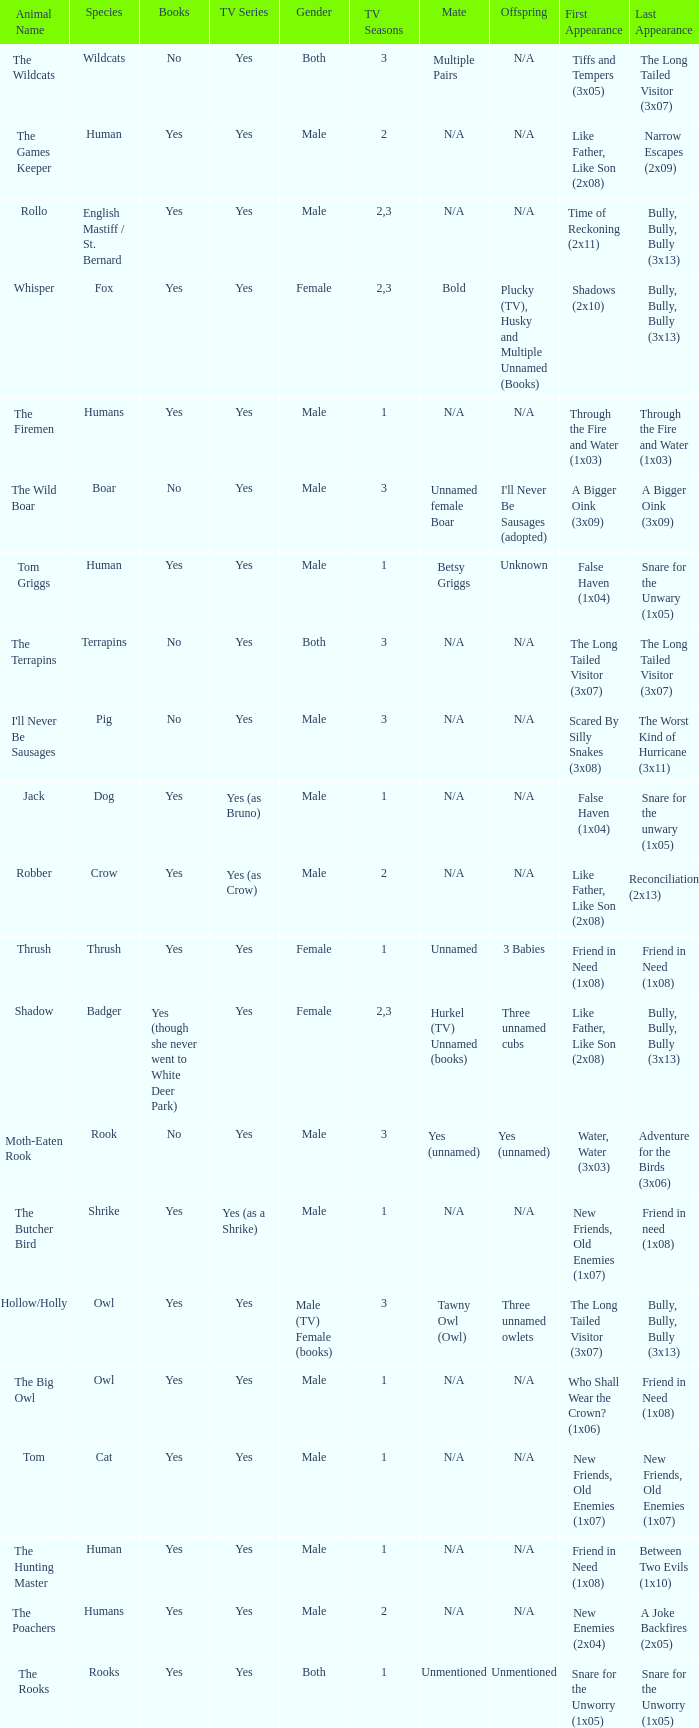What animal was yes for tv series and was a terrapins? The Terrapins. 